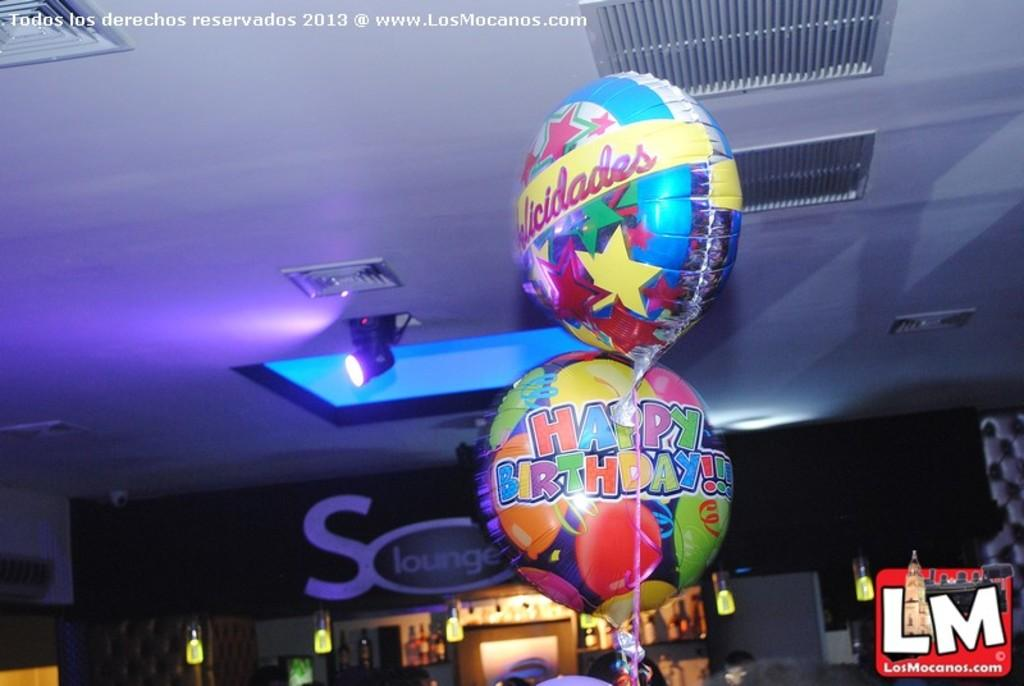<image>
Share a concise interpretation of the image provided. Two balloons one of which says Happy Birthday and they are multi colored and in a dark room with a light casting a purple glow. 